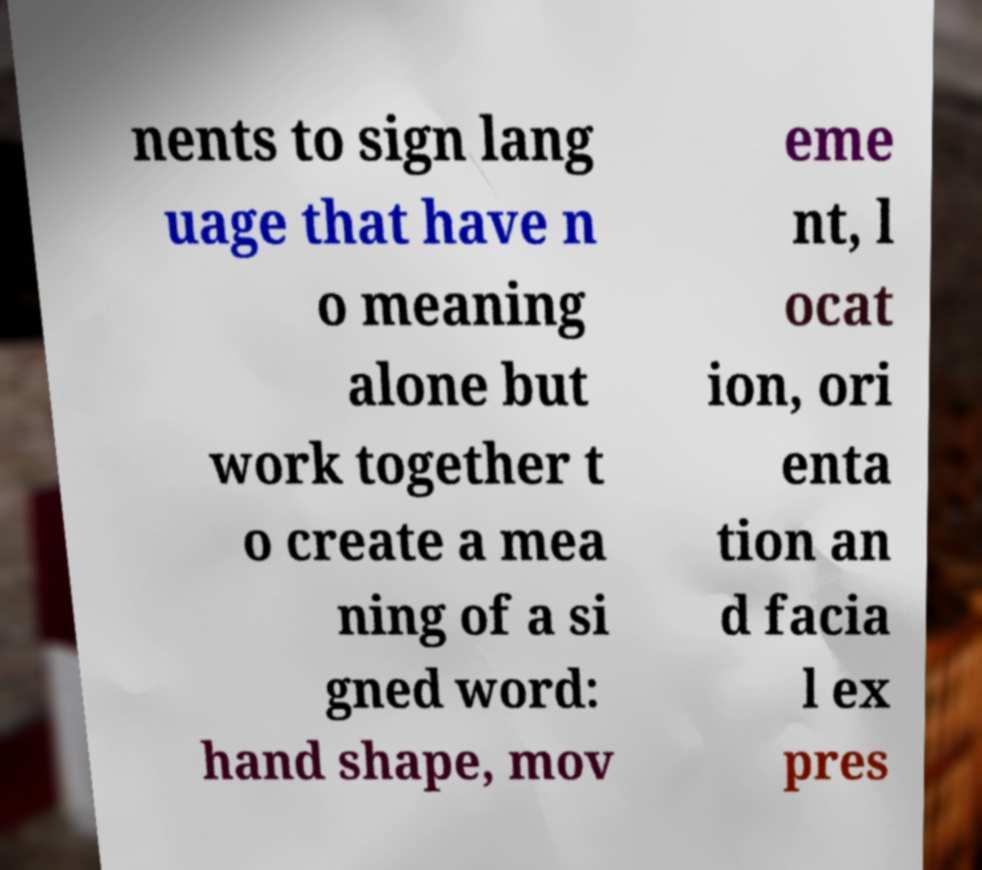What messages or text are displayed in this image? I need them in a readable, typed format. nents to sign lang uage that have n o meaning alone but work together t o create a mea ning of a si gned word: hand shape, mov eme nt, l ocat ion, ori enta tion an d facia l ex pres 